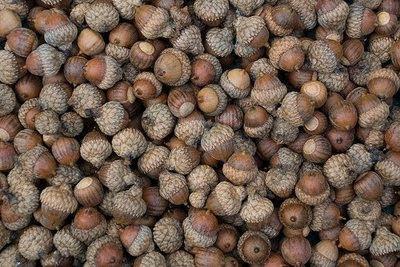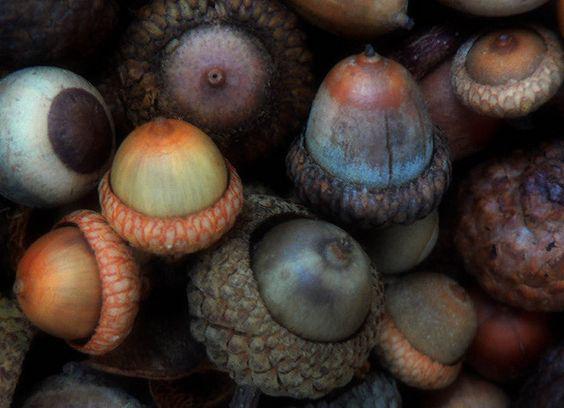The first image is the image on the left, the second image is the image on the right. Examine the images to the left and right. Is the description "In at least one  image there is a cracked acorn sitting on dirt and leaves on the ground." accurate? Answer yes or no. No. The first image is the image on the left, the second image is the image on the right. Assess this claim about the two images: "The acorns are lying on the ground.". Correct or not? Answer yes or no. No. 